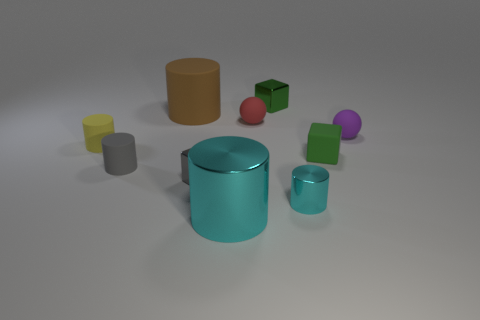There is a yellow object that is the same size as the gray block; what material is it?
Your response must be concise. Rubber. The block in front of the green thing to the right of the green block to the left of the small cyan metallic cylinder is made of what material?
Provide a succinct answer. Metal. Do the cylinder behind the yellow matte cylinder and the big shiny object have the same size?
Your answer should be compact. Yes. Are there more red matte things than yellow rubber cubes?
Provide a succinct answer. Yes. How many big objects are purple matte objects or red blocks?
Offer a very short reply. 0. How many other things are the same color as the small rubber block?
Offer a very short reply. 1. How many brown cylinders are made of the same material as the small gray cube?
Your response must be concise. 0. Is the color of the ball that is on the left side of the purple sphere the same as the large metallic thing?
Offer a terse response. No. How many brown things are either small blocks or metallic objects?
Provide a succinct answer. 0. Do the green block that is left of the tiny metal cylinder and the big cyan object have the same material?
Provide a succinct answer. Yes. 